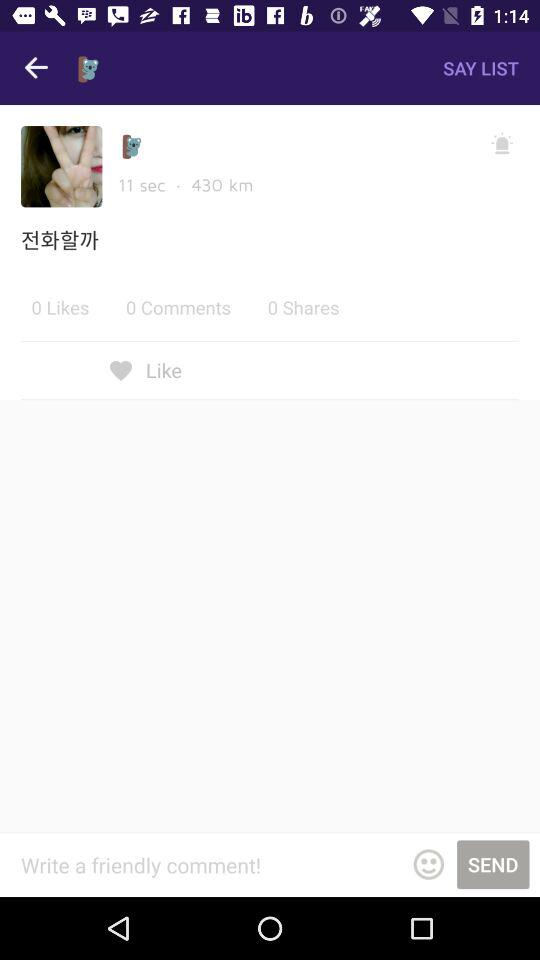How many more likes does the post have than shares?
Answer the question using a single word or phrase. 0 